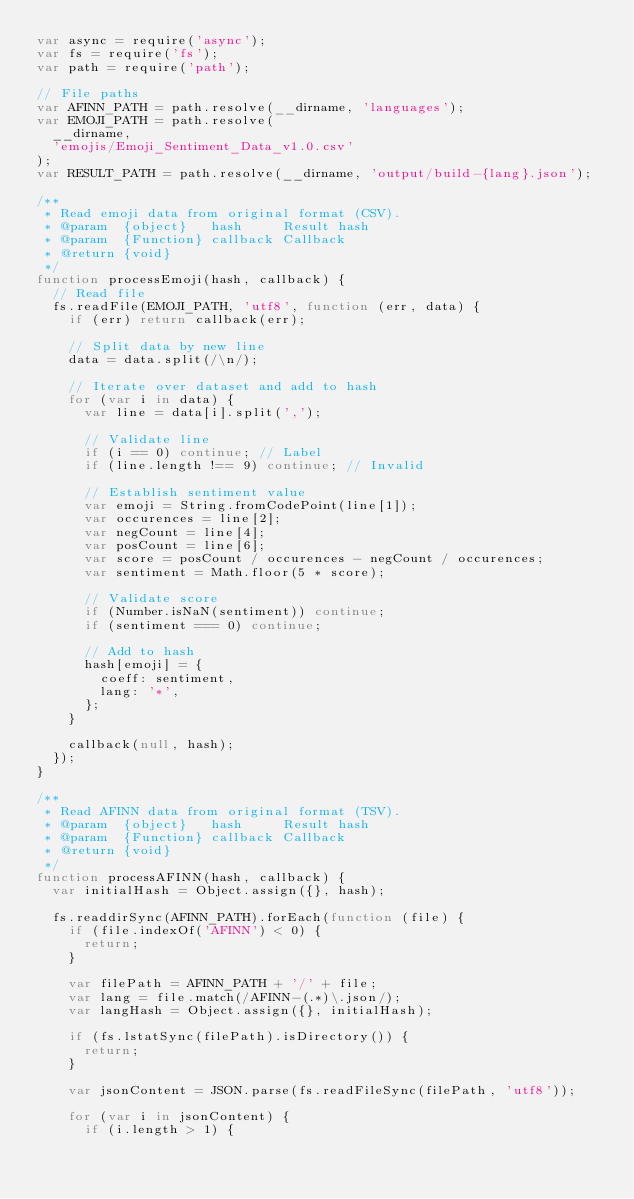Convert code to text. <code><loc_0><loc_0><loc_500><loc_500><_JavaScript_>var async = require('async');
var fs = require('fs');
var path = require('path');

// File paths
var AFINN_PATH = path.resolve(__dirname, 'languages');
var EMOJI_PATH = path.resolve(
  __dirname,
  'emojis/Emoji_Sentiment_Data_v1.0.csv'
);
var RESULT_PATH = path.resolve(__dirname, 'output/build-{lang}.json');

/**
 * Read emoji data from original format (CSV).
 * @param  {object}   hash     Result hash
 * @param  {Function} callback Callback
 * @return {void}
 */
function processEmoji(hash, callback) {
  // Read file
  fs.readFile(EMOJI_PATH, 'utf8', function (err, data) {
    if (err) return callback(err);

    // Split data by new line
    data = data.split(/\n/);

    // Iterate over dataset and add to hash
    for (var i in data) {
      var line = data[i].split(',');

      // Validate line
      if (i == 0) continue; // Label
      if (line.length !== 9) continue; // Invalid

      // Establish sentiment value
      var emoji = String.fromCodePoint(line[1]);
      var occurences = line[2];
      var negCount = line[4];
      var posCount = line[6];
      var score = posCount / occurences - negCount / occurences;
      var sentiment = Math.floor(5 * score);

      // Validate score
      if (Number.isNaN(sentiment)) continue;
      if (sentiment === 0) continue;

      // Add to hash
      hash[emoji] = {
        coeff: sentiment,
        lang: '*',
      };
    }

    callback(null, hash);
  });
}

/**
 * Read AFINN data from original format (TSV).
 * @param  {object}   hash     Result hash
 * @param  {Function} callback Callback
 * @return {void}
 */
function processAFINN(hash, callback) {
  var initialHash = Object.assign({}, hash);

  fs.readdirSync(AFINN_PATH).forEach(function (file) {
    if (file.indexOf('AFINN') < 0) {
      return;
    }

    var filePath = AFINN_PATH + '/' + file;
    var lang = file.match(/AFINN-(.*)\.json/);
    var langHash = Object.assign({}, initialHash);

    if (fs.lstatSync(filePath).isDirectory()) {
      return;
    }

    var jsonContent = JSON.parse(fs.readFileSync(filePath, 'utf8'));

    for (var i in jsonContent) {
      if (i.length > 1) {</code> 